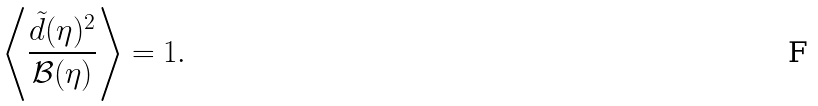Convert formula to latex. <formula><loc_0><loc_0><loc_500><loc_500>\left \langle \frac { \tilde { d } ( \eta ) ^ { 2 } } { \mathcal { B } ( \eta ) } \right \rangle = 1 .</formula> 